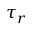<formula> <loc_0><loc_0><loc_500><loc_500>\tau _ { r }</formula> 